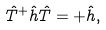<formula> <loc_0><loc_0><loc_500><loc_500>\hat { T } ^ { + } \hat { h } \hat { T } = + \hat { h } ,</formula> 